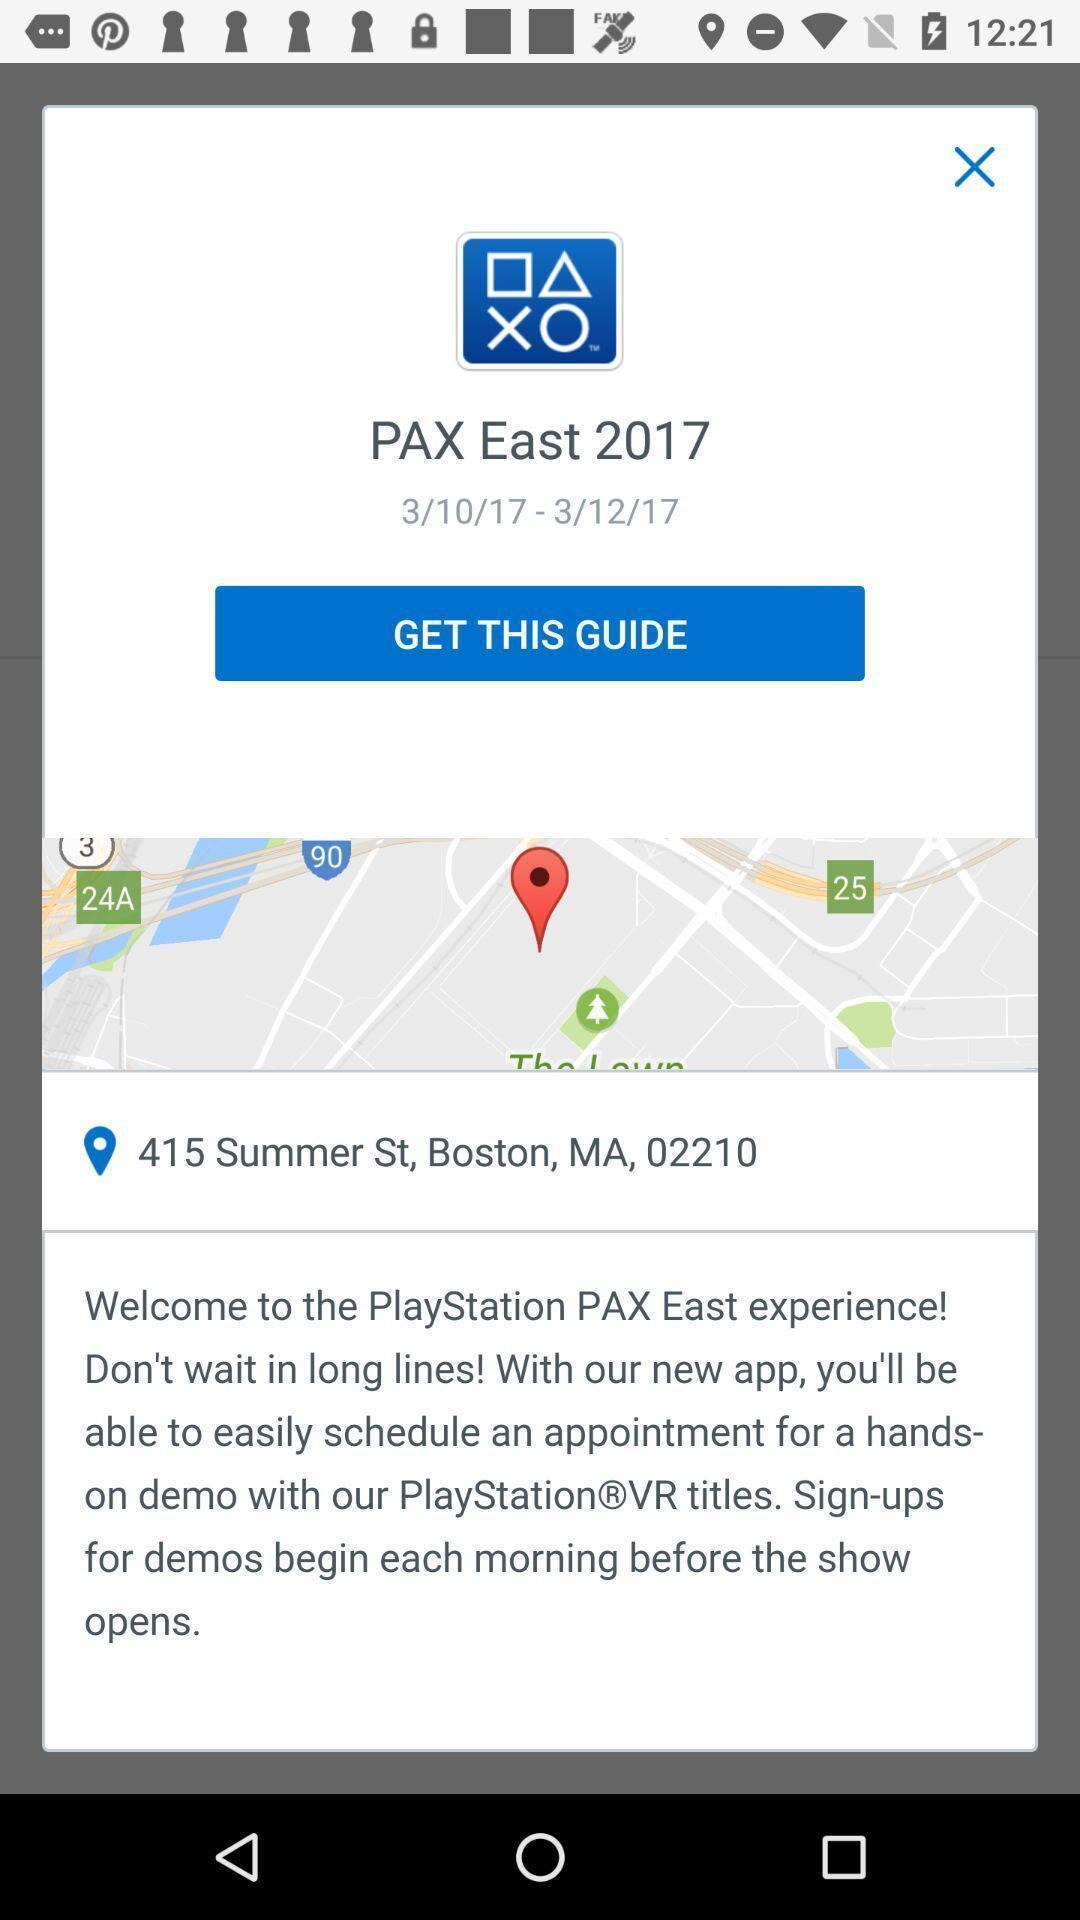Provide a textual representation of this image. Welcome page. 